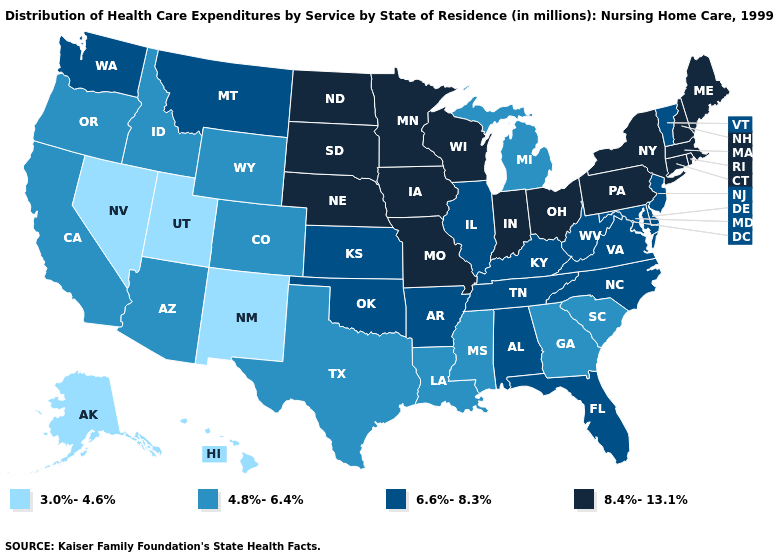What is the value of New York?
Be succinct. 8.4%-13.1%. Among the states that border Idaho , does Wyoming have the highest value?
Keep it brief. No. Name the states that have a value in the range 3.0%-4.6%?
Short answer required. Alaska, Hawaii, Nevada, New Mexico, Utah. What is the lowest value in states that border Florida?
Answer briefly. 4.8%-6.4%. Does Hawaii have the lowest value in the USA?
Short answer required. Yes. Among the states that border North Carolina , does Tennessee have the lowest value?
Short answer required. No. What is the value of Kentucky?
Concise answer only. 6.6%-8.3%. Which states have the lowest value in the USA?
Keep it brief. Alaska, Hawaii, Nevada, New Mexico, Utah. Does Wyoming have a lower value than North Carolina?
Keep it brief. Yes. Which states have the lowest value in the USA?
Keep it brief. Alaska, Hawaii, Nevada, New Mexico, Utah. How many symbols are there in the legend?
Answer briefly. 4. Which states have the lowest value in the West?
Quick response, please. Alaska, Hawaii, Nevada, New Mexico, Utah. What is the highest value in the MidWest ?
Write a very short answer. 8.4%-13.1%. What is the highest value in states that border Louisiana?
Write a very short answer. 6.6%-8.3%. 